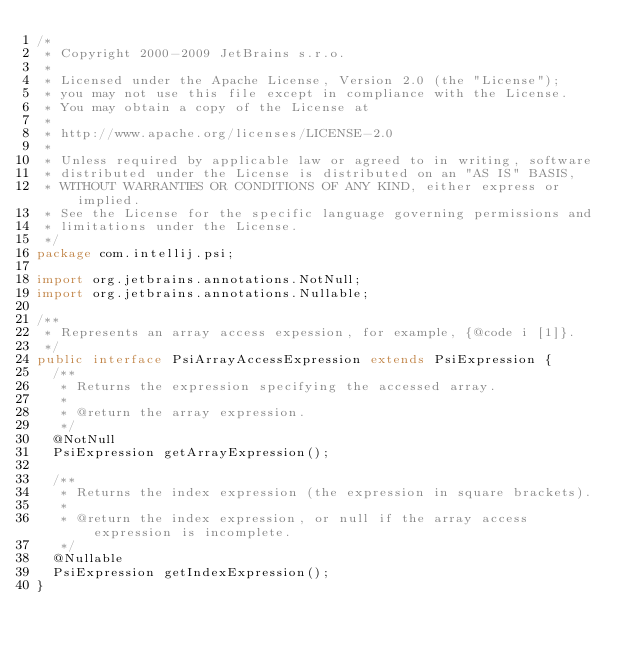Convert code to text. <code><loc_0><loc_0><loc_500><loc_500><_Java_>/*
 * Copyright 2000-2009 JetBrains s.r.o.
 *
 * Licensed under the Apache License, Version 2.0 (the "License");
 * you may not use this file except in compliance with the License.
 * You may obtain a copy of the License at
 *
 * http://www.apache.org/licenses/LICENSE-2.0
 *
 * Unless required by applicable law or agreed to in writing, software
 * distributed under the License is distributed on an "AS IS" BASIS,
 * WITHOUT WARRANTIES OR CONDITIONS OF ANY KIND, either express or implied.
 * See the License for the specific language governing permissions and
 * limitations under the License.
 */
package com.intellij.psi;

import org.jetbrains.annotations.NotNull;
import org.jetbrains.annotations.Nullable;

/**
 * Represents an array access expession, for example, {@code i [1]}.
 */
public interface PsiArrayAccessExpression extends PsiExpression {
  /**
   * Returns the expression specifying the accessed array.
   *
   * @return the array expression.
   */
  @NotNull
  PsiExpression getArrayExpression();

  /**
   * Returns the index expression (the expression in square brackets).
   *
   * @return the index expression, or null if the array access expression is incomplete.
   */
  @Nullable
  PsiExpression getIndexExpression();
}
</code> 